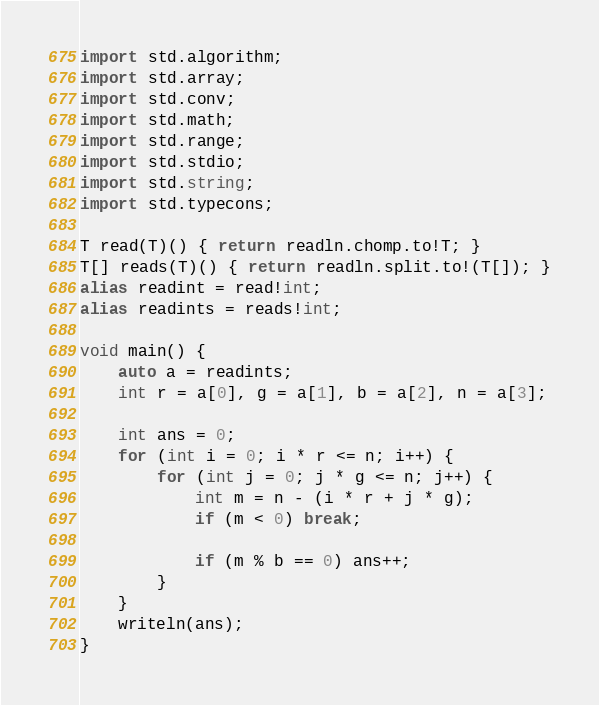Convert code to text. <code><loc_0><loc_0><loc_500><loc_500><_D_>import std.algorithm;
import std.array;
import std.conv;
import std.math;
import std.range;
import std.stdio;
import std.string;
import std.typecons;

T read(T)() { return readln.chomp.to!T; }
T[] reads(T)() { return readln.split.to!(T[]); }
alias readint = read!int;
alias readints = reads!int;

void main() {
    auto a = readints;
    int r = a[0], g = a[1], b = a[2], n = a[3];

    int ans = 0;
    for (int i = 0; i * r <= n; i++) {
        for (int j = 0; j * g <= n; j++) {
            int m = n - (i * r + j * g);
            if (m < 0) break;

            if (m % b == 0) ans++;
        }
    }
    writeln(ans);
}

</code> 